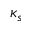<formula> <loc_0><loc_0><loc_500><loc_500>\kappa _ { s }</formula> 